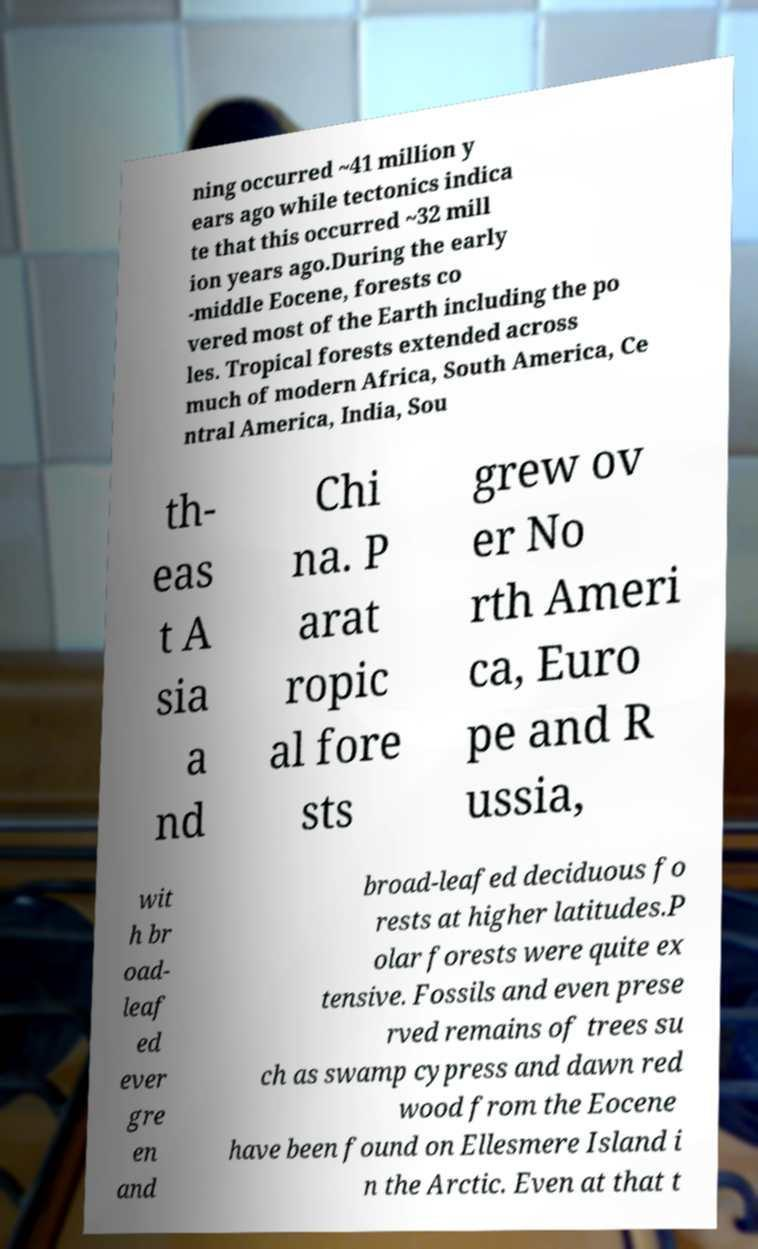Please read and relay the text visible in this image. What does it say? ning occurred ~41 million y ears ago while tectonics indica te that this occurred ~32 mill ion years ago.During the early -middle Eocene, forests co vered most of the Earth including the po les. Tropical forests extended across much of modern Africa, South America, Ce ntral America, India, Sou th- eas t A sia a nd Chi na. P arat ropic al fore sts grew ov er No rth Ameri ca, Euro pe and R ussia, wit h br oad- leaf ed ever gre en and broad-leafed deciduous fo rests at higher latitudes.P olar forests were quite ex tensive. Fossils and even prese rved remains of trees su ch as swamp cypress and dawn red wood from the Eocene have been found on Ellesmere Island i n the Arctic. Even at that t 